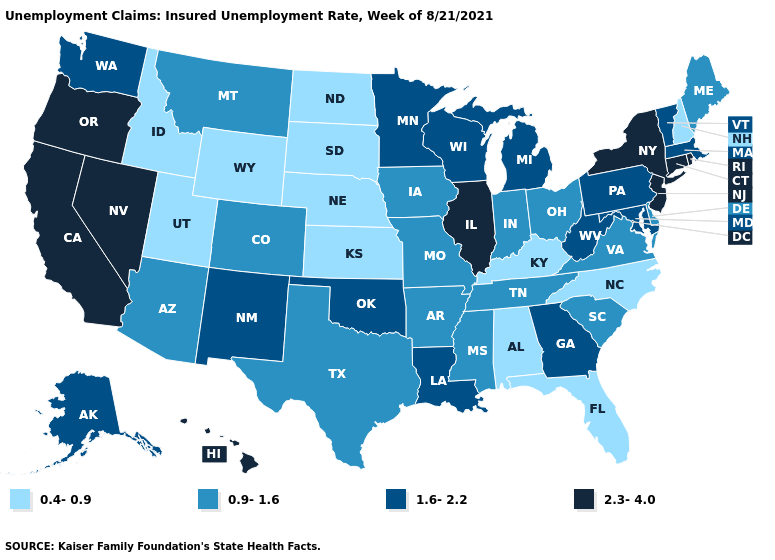What is the value of Alaska?
Concise answer only. 1.6-2.2. Among the states that border Vermont , which have the highest value?
Be succinct. New York. Among the states that border Wisconsin , which have the lowest value?
Concise answer only. Iowa. Does Louisiana have a lower value than Nevada?
Keep it brief. Yes. What is the lowest value in the USA?
Keep it brief. 0.4-0.9. Name the states that have a value in the range 0.4-0.9?
Concise answer only. Alabama, Florida, Idaho, Kansas, Kentucky, Nebraska, New Hampshire, North Carolina, North Dakota, South Dakota, Utah, Wyoming. Does Alaska have the same value as Idaho?
Quick response, please. No. Among the states that border South Dakota , which have the lowest value?
Short answer required. Nebraska, North Dakota, Wyoming. Does Connecticut have the same value as Oregon?
Be succinct. Yes. Which states have the lowest value in the MidWest?
Keep it brief. Kansas, Nebraska, North Dakota, South Dakota. What is the highest value in states that border Vermont?
Concise answer only. 2.3-4.0. Is the legend a continuous bar?
Be succinct. No. Which states have the highest value in the USA?
Keep it brief. California, Connecticut, Hawaii, Illinois, Nevada, New Jersey, New York, Oregon, Rhode Island. What is the lowest value in the USA?
Short answer required. 0.4-0.9. Among the states that border New Hampshire , which have the lowest value?
Quick response, please. Maine. 